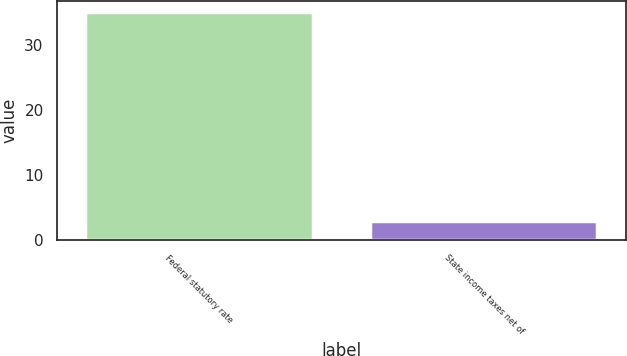<chart> <loc_0><loc_0><loc_500><loc_500><bar_chart><fcel>Federal statutory rate<fcel>State income taxes net of<nl><fcel>35<fcel>2.9<nl></chart> 